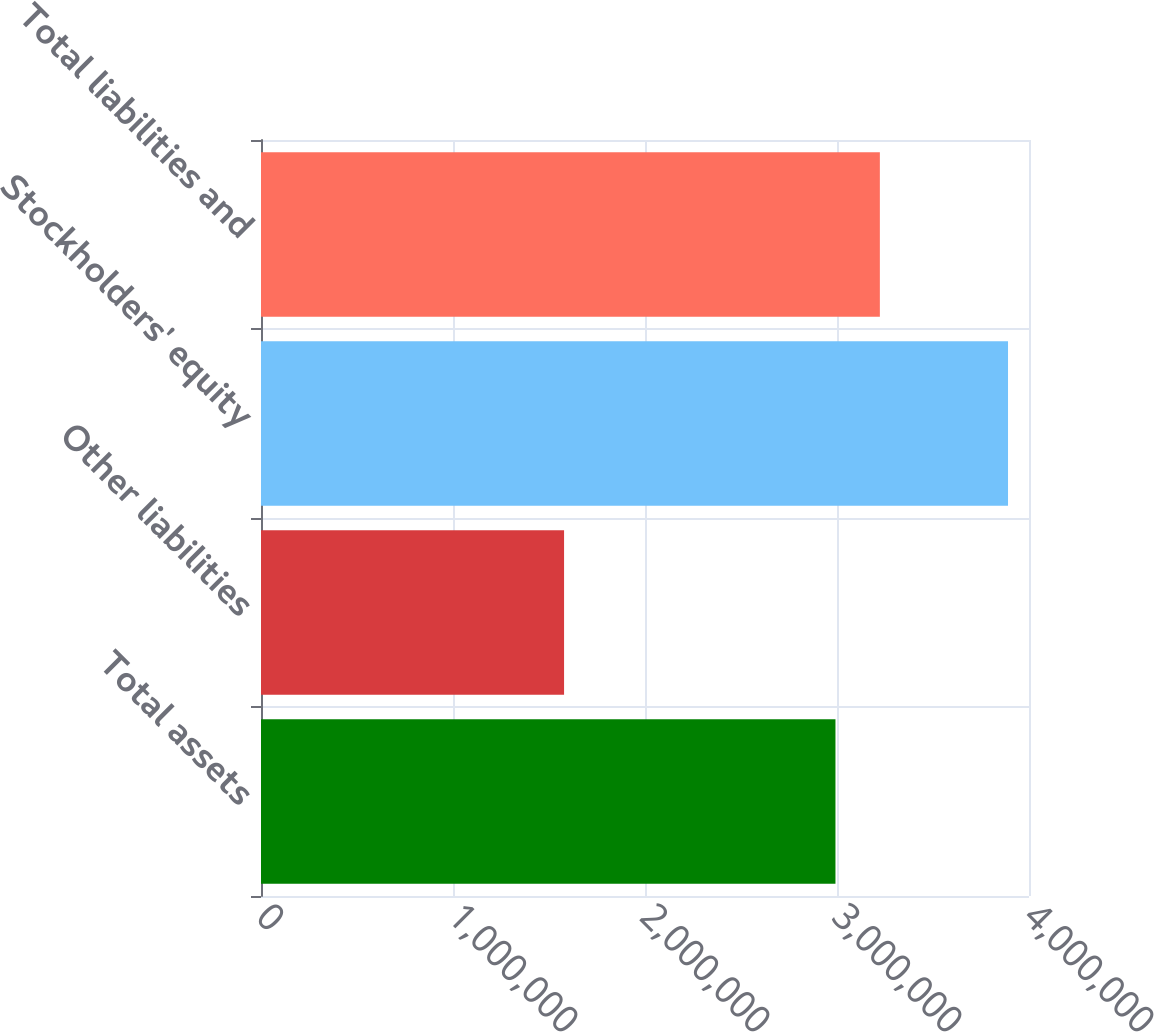<chart> <loc_0><loc_0><loc_500><loc_500><bar_chart><fcel>Total assets<fcel>Other liabilities<fcel>Stockholders' equity<fcel>Total liabilities and<nl><fcel>2.99198e+06<fcel>1.57846e+06<fcel>3.89072e+06<fcel>3.22321e+06<nl></chart> 